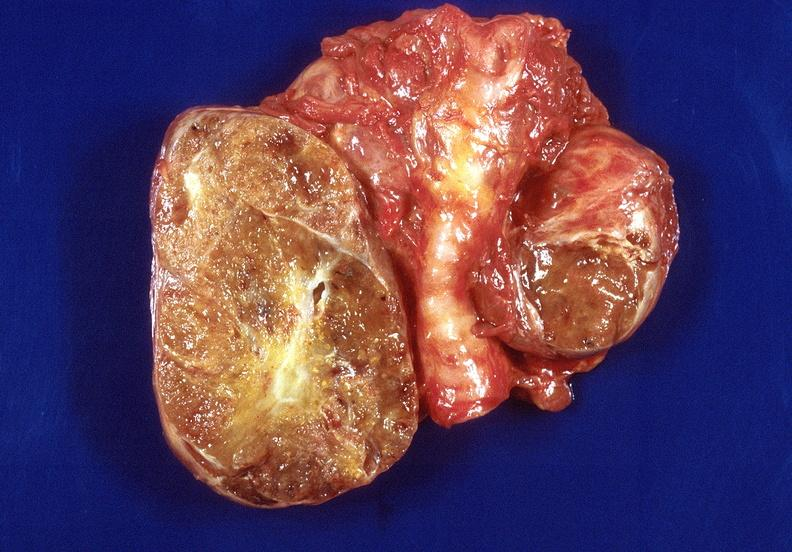s endocrine present?
Answer the question using a single word or phrase. Yes 